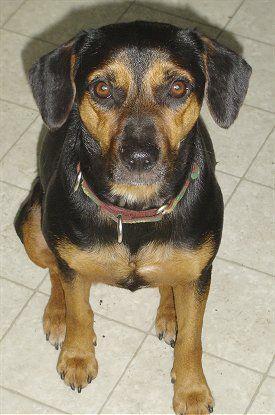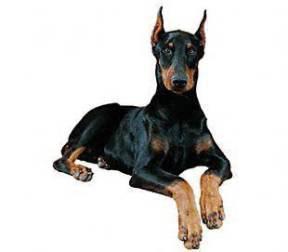The first image is the image on the left, the second image is the image on the right. Evaluate the accuracy of this statement regarding the images: "One Doberman's ears are both raised.". Is it true? Answer yes or no. Yes. The first image is the image on the left, the second image is the image on the right. Assess this claim about the two images: "The right image shows a forward-facing reclining two-tone adult doberman with erect pointy ears.". Correct or not? Answer yes or no. Yes. 